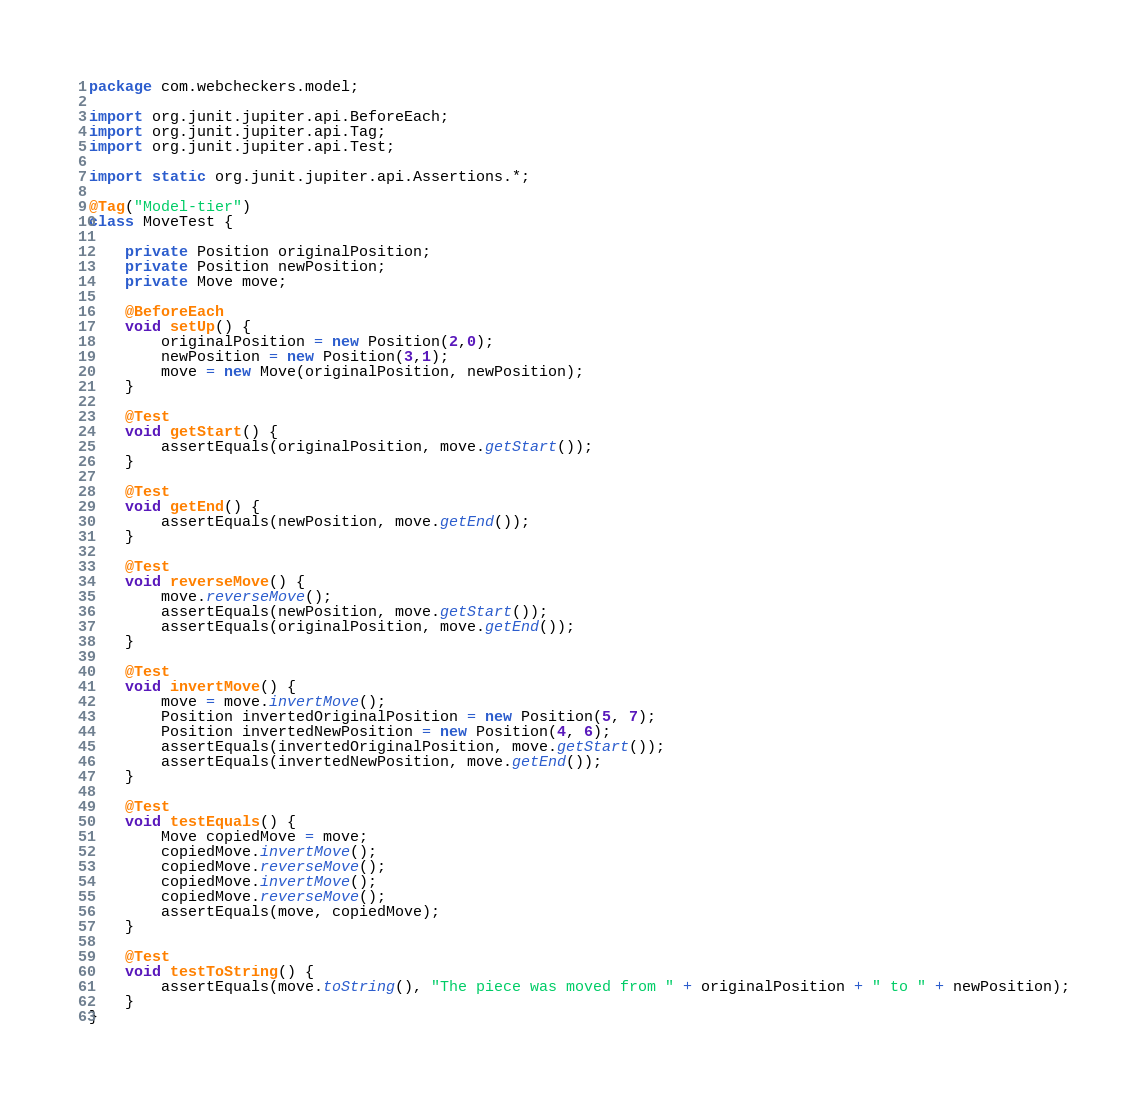<code> <loc_0><loc_0><loc_500><loc_500><_Java_>package com.webcheckers.model;

import org.junit.jupiter.api.BeforeEach;
import org.junit.jupiter.api.Tag;
import org.junit.jupiter.api.Test;

import static org.junit.jupiter.api.Assertions.*;

@Tag("Model-tier")
class MoveTest {

    private Position originalPosition;
    private Position newPosition;
    private Move move;

    @BeforeEach
    void setUp() {
        originalPosition = new Position(2,0);
        newPosition = new Position(3,1);
        move = new Move(originalPosition, newPosition);
    }

    @Test
    void getStart() {
        assertEquals(originalPosition, move.getStart());
    }

    @Test
    void getEnd() {
        assertEquals(newPosition, move.getEnd());
    }

    @Test
    void reverseMove() {
        move.reverseMove();
        assertEquals(newPosition, move.getStart());
        assertEquals(originalPosition, move.getEnd());
    }

    @Test
    void invertMove() {
        move = move.invertMove();
        Position invertedOriginalPosition = new Position(5, 7);
        Position invertedNewPosition = new Position(4, 6);
        assertEquals(invertedOriginalPosition, move.getStart());
        assertEquals(invertedNewPosition, move.getEnd());
    }

    @Test
    void testEquals() {
        Move copiedMove = move;
        copiedMove.invertMove();
        copiedMove.reverseMove();
        copiedMove.invertMove();
        copiedMove.reverseMove();
        assertEquals(move, copiedMove);
    }

    @Test
    void testToString() {
        assertEquals(move.toString(), "The piece was moved from " + originalPosition + " to " + newPosition);
    }
}</code> 